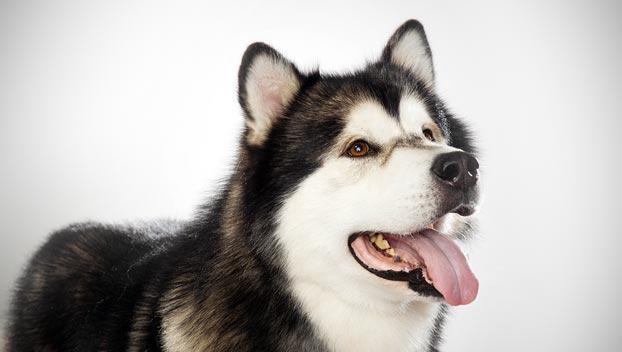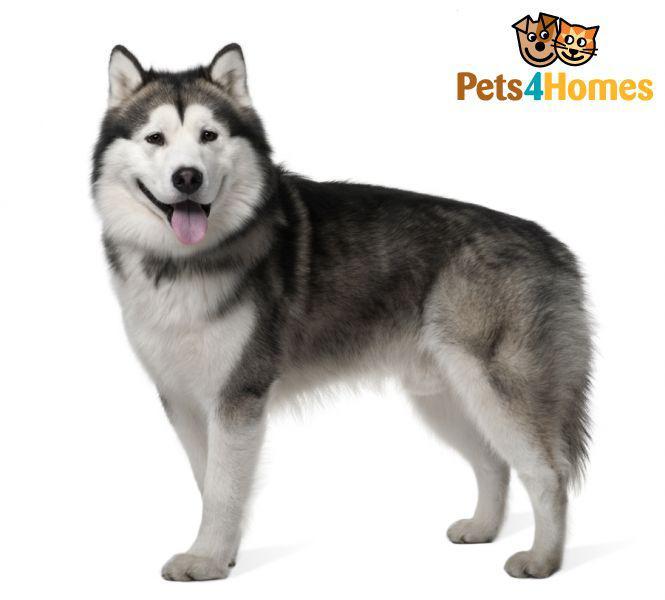The first image is the image on the left, the second image is the image on the right. Analyze the images presented: Is the assertion "All dogs are standing, and each image contains a dog with an upturned, curled tail." valid? Answer yes or no. No. The first image is the image on the left, the second image is the image on the right. For the images shown, is this caption "There are only two dogs, and both of them are showing their tongues." true? Answer yes or no. Yes. 